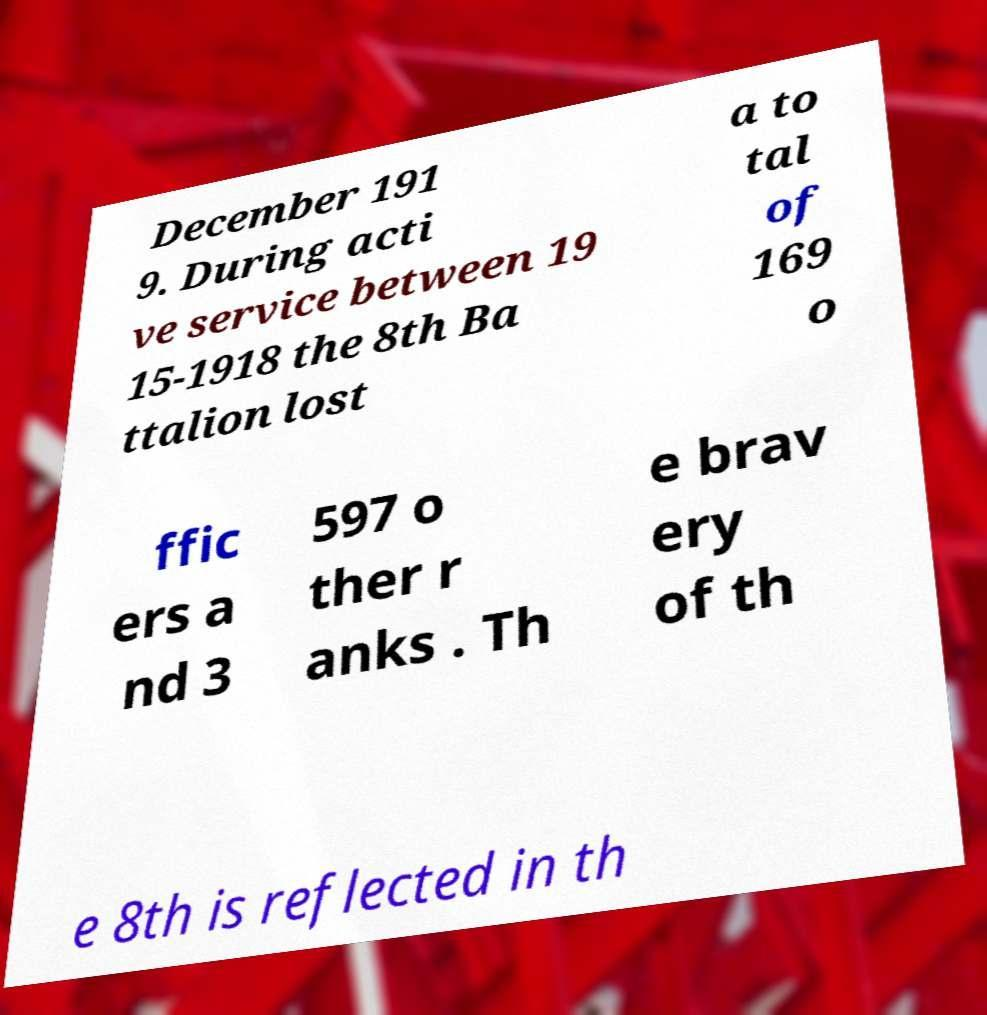Please read and relay the text visible in this image. What does it say? December 191 9. During acti ve service between 19 15-1918 the 8th Ba ttalion lost a to tal of 169 o ffic ers a nd 3 597 o ther r anks . Th e brav ery of th e 8th is reflected in th 